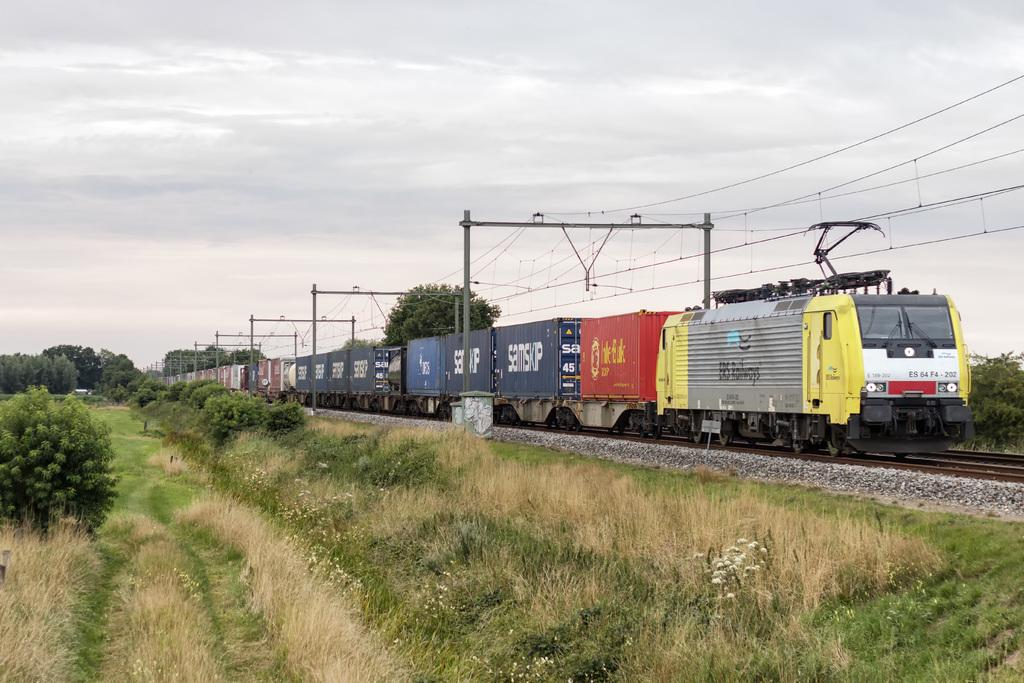<image>
Present a compact description of the photo's key features. Train ES 64 F4 - 202 is pulling many cars through a grassy field. 